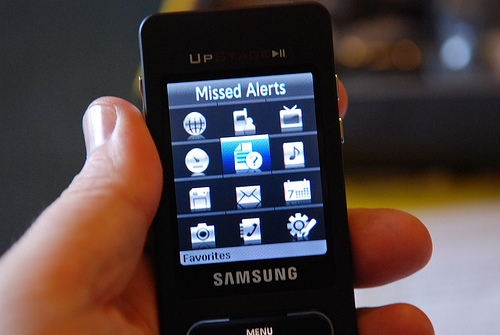What model of phone is shown in the image? The image depicts a Samsung feature phone, but the specific model is not clear from the image. It has a classic navigation button layout and a small screen displaying icons for various functions such as 'Missed Alerts' and 'Favorites'. 